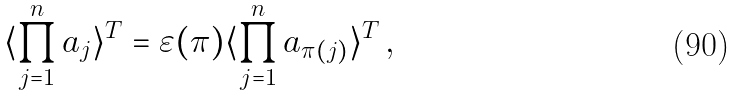<formula> <loc_0><loc_0><loc_500><loc_500>\langle \prod ^ { n } _ { j = 1 } a _ { j } \rangle ^ { T } = \varepsilon ( \pi ) \langle \prod ^ { n } _ { j = 1 } a _ { \pi ( j ) } \rangle ^ { T } \, ,</formula> 